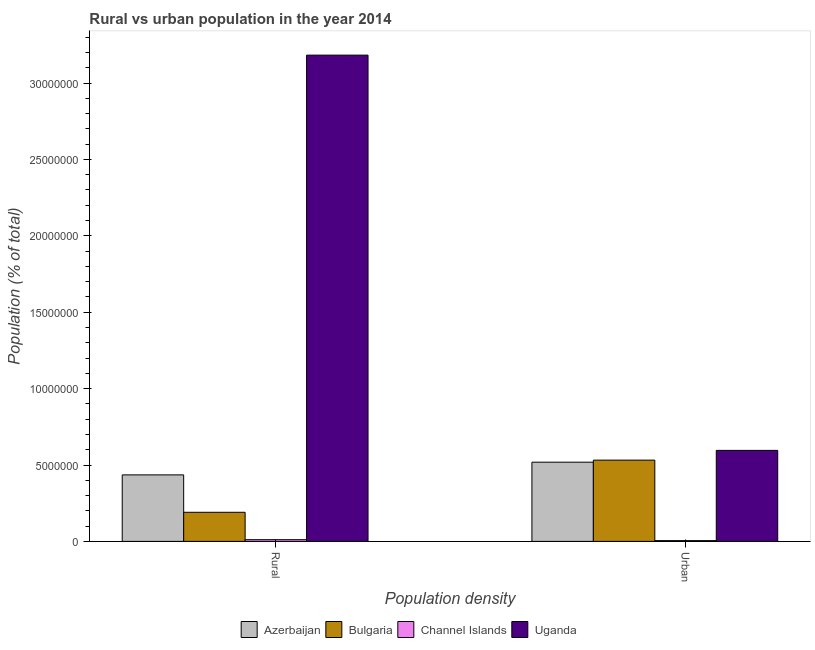How many groups of bars are there?
Provide a succinct answer. 2. Are the number of bars on each tick of the X-axis equal?
Your response must be concise. Yes. What is the label of the 2nd group of bars from the left?
Provide a short and direct response. Urban. What is the urban population density in Bulgaria?
Keep it short and to the point. 5.32e+06. Across all countries, what is the maximum rural population density?
Your answer should be compact. 3.18e+07. Across all countries, what is the minimum rural population density?
Ensure brevity in your answer.  1.12e+05. In which country was the rural population density maximum?
Your answer should be very brief. Uganda. In which country was the rural population density minimum?
Your answer should be very brief. Channel Islands. What is the total urban population density in the graph?
Your response must be concise. 1.65e+07. What is the difference between the urban population density in Azerbaijan and that in Bulgaria?
Keep it short and to the point. -1.34e+05. What is the difference between the urban population density in Azerbaijan and the rural population density in Channel Islands?
Make the answer very short. 5.07e+06. What is the average rural population density per country?
Keep it short and to the point. 9.55e+06. What is the difference between the urban population density and rural population density in Channel Islands?
Your answer should be compact. -6.07e+04. In how many countries, is the urban population density greater than 18000000 %?
Give a very brief answer. 0. What is the ratio of the rural population density in Uganda to that in Channel Islands?
Your response must be concise. 284.62. In how many countries, is the rural population density greater than the average rural population density taken over all countries?
Provide a succinct answer. 1. What does the 3rd bar from the left in Urban represents?
Provide a succinct answer. Channel Islands. What does the 2nd bar from the right in Urban represents?
Ensure brevity in your answer.  Channel Islands. How many bars are there?
Offer a very short reply. 8. Are all the bars in the graph horizontal?
Your response must be concise. No. How many countries are there in the graph?
Your answer should be very brief. 4. What is the difference between two consecutive major ticks on the Y-axis?
Give a very brief answer. 5.00e+06. Are the values on the major ticks of Y-axis written in scientific E-notation?
Offer a very short reply. No. What is the title of the graph?
Offer a very short reply. Rural vs urban population in the year 2014. What is the label or title of the X-axis?
Offer a very short reply. Population density. What is the label or title of the Y-axis?
Your answer should be very brief. Population (% of total). What is the Population (% of total) in Azerbaijan in Rural?
Your answer should be compact. 4.35e+06. What is the Population (% of total) in Bulgaria in Rural?
Your response must be concise. 1.91e+06. What is the Population (% of total) in Channel Islands in Rural?
Make the answer very short. 1.12e+05. What is the Population (% of total) of Uganda in Rural?
Keep it short and to the point. 3.18e+07. What is the Population (% of total) in Azerbaijan in Urban?
Offer a terse response. 5.18e+06. What is the Population (% of total) in Bulgaria in Urban?
Make the answer very short. 5.32e+06. What is the Population (% of total) in Channel Islands in Urban?
Offer a terse response. 5.11e+04. What is the Population (% of total) in Uganda in Urban?
Provide a succinct answer. 5.96e+06. Across all Population density, what is the maximum Population (% of total) of Azerbaijan?
Make the answer very short. 5.18e+06. Across all Population density, what is the maximum Population (% of total) in Bulgaria?
Offer a very short reply. 5.32e+06. Across all Population density, what is the maximum Population (% of total) of Channel Islands?
Your answer should be very brief. 1.12e+05. Across all Population density, what is the maximum Population (% of total) of Uganda?
Your response must be concise. 3.18e+07. Across all Population density, what is the minimum Population (% of total) of Azerbaijan?
Offer a very short reply. 4.35e+06. Across all Population density, what is the minimum Population (% of total) of Bulgaria?
Provide a short and direct response. 1.91e+06. Across all Population density, what is the minimum Population (% of total) of Channel Islands?
Make the answer very short. 5.11e+04. Across all Population density, what is the minimum Population (% of total) in Uganda?
Offer a very short reply. 5.96e+06. What is the total Population (% of total) of Azerbaijan in the graph?
Make the answer very short. 9.54e+06. What is the total Population (% of total) in Bulgaria in the graph?
Provide a short and direct response. 7.22e+06. What is the total Population (% of total) of Channel Islands in the graph?
Offer a very short reply. 1.63e+05. What is the total Population (% of total) in Uganda in the graph?
Provide a short and direct response. 3.78e+07. What is the difference between the Population (% of total) of Azerbaijan in Rural and that in Urban?
Provide a succinct answer. -8.31e+05. What is the difference between the Population (% of total) in Bulgaria in Rural and that in Urban?
Offer a very short reply. -3.41e+06. What is the difference between the Population (% of total) in Channel Islands in Rural and that in Urban?
Offer a very short reply. 6.07e+04. What is the difference between the Population (% of total) of Uganda in Rural and that in Urban?
Offer a very short reply. 2.59e+07. What is the difference between the Population (% of total) of Azerbaijan in Rural and the Population (% of total) of Bulgaria in Urban?
Offer a very short reply. -9.65e+05. What is the difference between the Population (% of total) of Azerbaijan in Rural and the Population (% of total) of Channel Islands in Urban?
Your response must be concise. 4.30e+06. What is the difference between the Population (% of total) in Azerbaijan in Rural and the Population (% of total) in Uganda in Urban?
Keep it short and to the point. -1.60e+06. What is the difference between the Population (% of total) of Bulgaria in Rural and the Population (% of total) of Channel Islands in Urban?
Keep it short and to the point. 1.85e+06. What is the difference between the Population (% of total) in Bulgaria in Rural and the Population (% of total) in Uganda in Urban?
Your answer should be compact. -4.05e+06. What is the difference between the Population (% of total) in Channel Islands in Rural and the Population (% of total) in Uganda in Urban?
Make the answer very short. -5.85e+06. What is the average Population (% of total) of Azerbaijan per Population density?
Ensure brevity in your answer.  4.77e+06. What is the average Population (% of total) in Bulgaria per Population density?
Make the answer very short. 3.61e+06. What is the average Population (% of total) in Channel Islands per Population density?
Keep it short and to the point. 8.15e+04. What is the average Population (% of total) of Uganda per Population density?
Make the answer very short. 1.89e+07. What is the difference between the Population (% of total) of Azerbaijan and Population (% of total) of Bulgaria in Rural?
Your answer should be very brief. 2.45e+06. What is the difference between the Population (% of total) in Azerbaijan and Population (% of total) in Channel Islands in Rural?
Your answer should be compact. 4.24e+06. What is the difference between the Population (% of total) of Azerbaijan and Population (% of total) of Uganda in Rural?
Your answer should be very brief. -2.75e+07. What is the difference between the Population (% of total) in Bulgaria and Population (% of total) in Channel Islands in Rural?
Ensure brevity in your answer.  1.79e+06. What is the difference between the Population (% of total) of Bulgaria and Population (% of total) of Uganda in Rural?
Provide a short and direct response. -2.99e+07. What is the difference between the Population (% of total) of Channel Islands and Population (% of total) of Uganda in Rural?
Offer a terse response. -3.17e+07. What is the difference between the Population (% of total) of Azerbaijan and Population (% of total) of Bulgaria in Urban?
Make the answer very short. -1.34e+05. What is the difference between the Population (% of total) of Azerbaijan and Population (% of total) of Channel Islands in Urban?
Give a very brief answer. 5.13e+06. What is the difference between the Population (% of total) in Azerbaijan and Population (% of total) in Uganda in Urban?
Keep it short and to the point. -7.73e+05. What is the difference between the Population (% of total) in Bulgaria and Population (% of total) in Channel Islands in Urban?
Make the answer very short. 5.27e+06. What is the difference between the Population (% of total) in Bulgaria and Population (% of total) in Uganda in Urban?
Offer a very short reply. -6.38e+05. What is the difference between the Population (% of total) in Channel Islands and Population (% of total) in Uganda in Urban?
Your response must be concise. -5.91e+06. What is the ratio of the Population (% of total) in Azerbaijan in Rural to that in Urban?
Provide a succinct answer. 0.84. What is the ratio of the Population (% of total) in Bulgaria in Rural to that in Urban?
Keep it short and to the point. 0.36. What is the ratio of the Population (% of total) of Channel Islands in Rural to that in Urban?
Provide a succinct answer. 2.19. What is the ratio of the Population (% of total) of Uganda in Rural to that in Urban?
Ensure brevity in your answer.  5.34. What is the difference between the highest and the second highest Population (% of total) in Azerbaijan?
Keep it short and to the point. 8.31e+05. What is the difference between the highest and the second highest Population (% of total) of Bulgaria?
Your answer should be very brief. 3.41e+06. What is the difference between the highest and the second highest Population (% of total) in Channel Islands?
Ensure brevity in your answer.  6.07e+04. What is the difference between the highest and the second highest Population (% of total) of Uganda?
Provide a succinct answer. 2.59e+07. What is the difference between the highest and the lowest Population (% of total) of Azerbaijan?
Offer a terse response. 8.31e+05. What is the difference between the highest and the lowest Population (% of total) in Bulgaria?
Your response must be concise. 3.41e+06. What is the difference between the highest and the lowest Population (% of total) in Channel Islands?
Offer a terse response. 6.07e+04. What is the difference between the highest and the lowest Population (% of total) of Uganda?
Ensure brevity in your answer.  2.59e+07. 